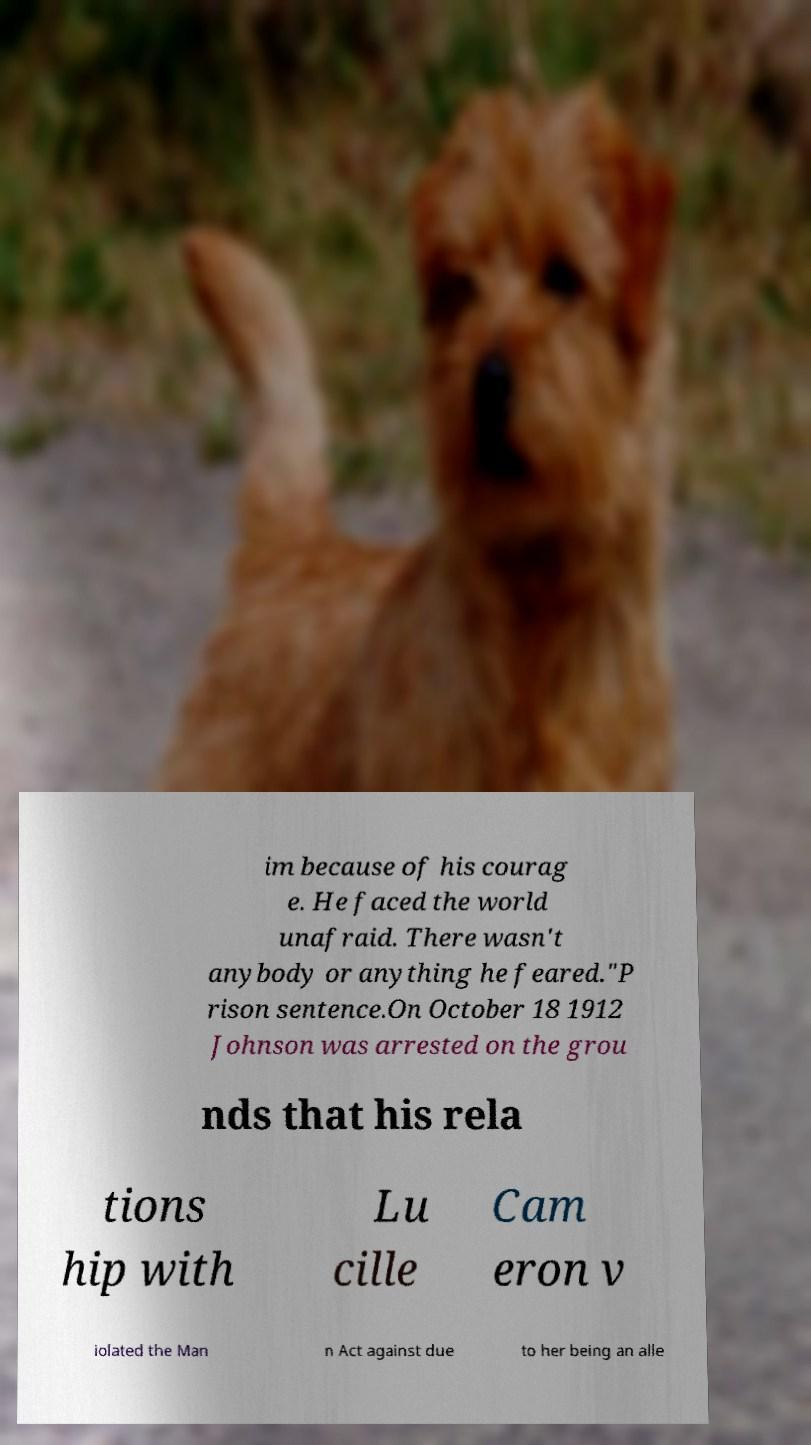Please identify and transcribe the text found in this image. im because of his courag e. He faced the world unafraid. There wasn't anybody or anything he feared."P rison sentence.On October 18 1912 Johnson was arrested on the grou nds that his rela tions hip with Lu cille Cam eron v iolated the Man n Act against due to her being an alle 